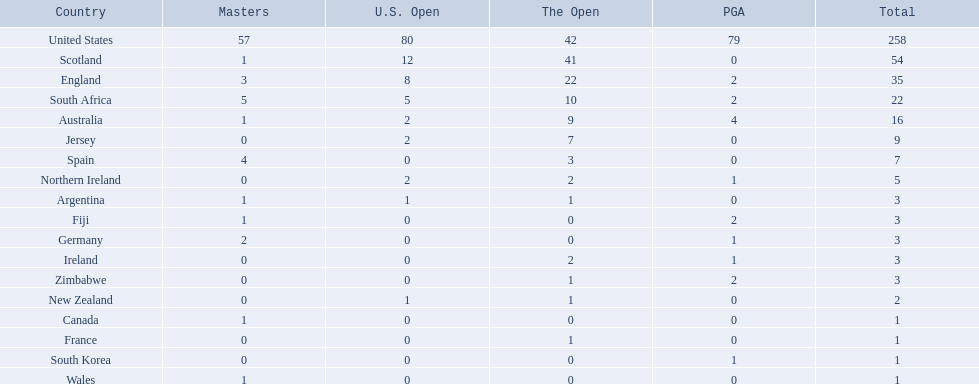Which of the countries listed are african? South Africa, Zimbabwe. Which of those has the least championship winning golfers? Zimbabwe. 